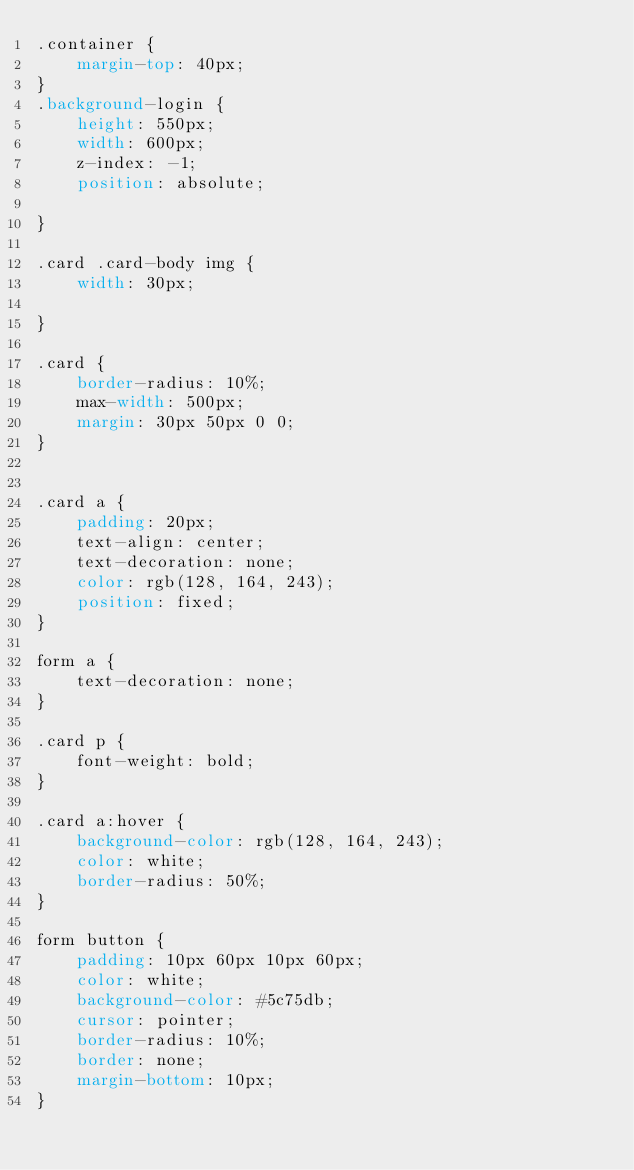<code> <loc_0><loc_0><loc_500><loc_500><_CSS_>.container {
    margin-top: 40px;
}
.background-login {
    height: 550px;
    width: 600px;
    z-index: -1;
    position: absolute;

}

.card .card-body img {
    width: 30px;

}

.card {
    border-radius: 10%;
    max-width: 500px;
    margin: 30px 50px 0 0;
}


.card a {
    padding: 20px;
    text-align: center;
    text-decoration: none;
    color: rgb(128, 164, 243);
    position: fixed;
}

form a {
    text-decoration: none;
}

.card p {
    font-weight: bold;
}

.card a:hover {
    background-color: rgb(128, 164, 243);
    color: white;
    border-radius: 50%;
}

form button {
    padding: 10px 60px 10px 60px;
    color: white;
    background-color: #5c75db;
    cursor: pointer;
    border-radius: 10%;
    border: none;
    margin-bottom: 10px;
}
</code> 